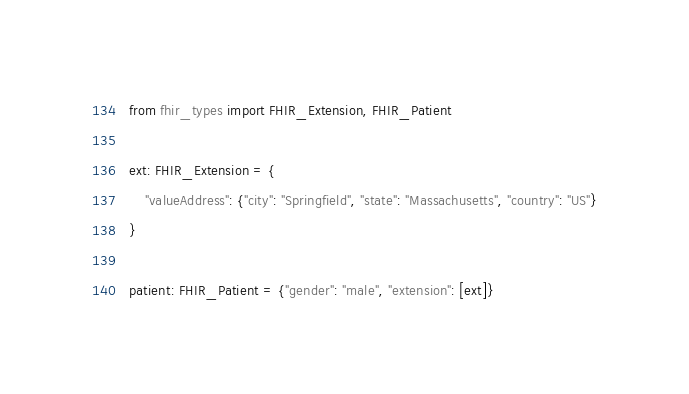<code> <loc_0><loc_0><loc_500><loc_500><_Python_>from fhir_types import FHIR_Extension, FHIR_Patient

ext: FHIR_Extension = {
    "valueAddress": {"city": "Springfield", "state": "Massachusetts", "country": "US"}
}

patient: FHIR_Patient = {"gender": "male", "extension": [ext]}
</code> 